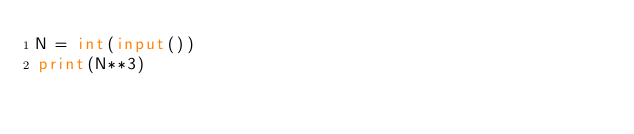<code> <loc_0><loc_0><loc_500><loc_500><_Python_>N = int(input())
print(N**3)</code> 